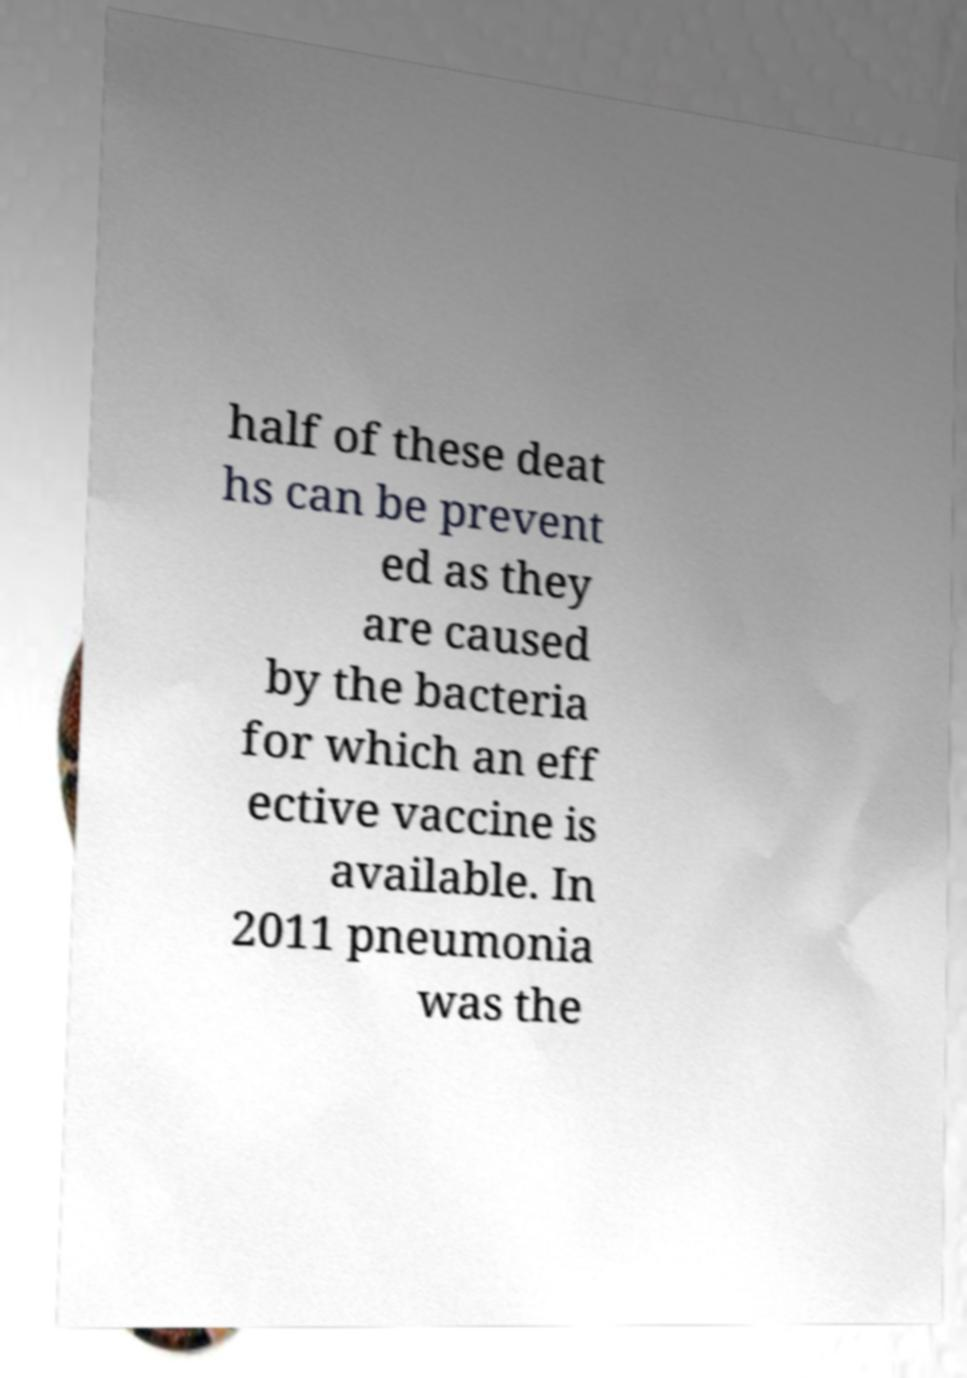I need the written content from this picture converted into text. Can you do that? half of these deat hs can be prevent ed as they are caused by the bacteria for which an eff ective vaccine is available. In 2011 pneumonia was the 